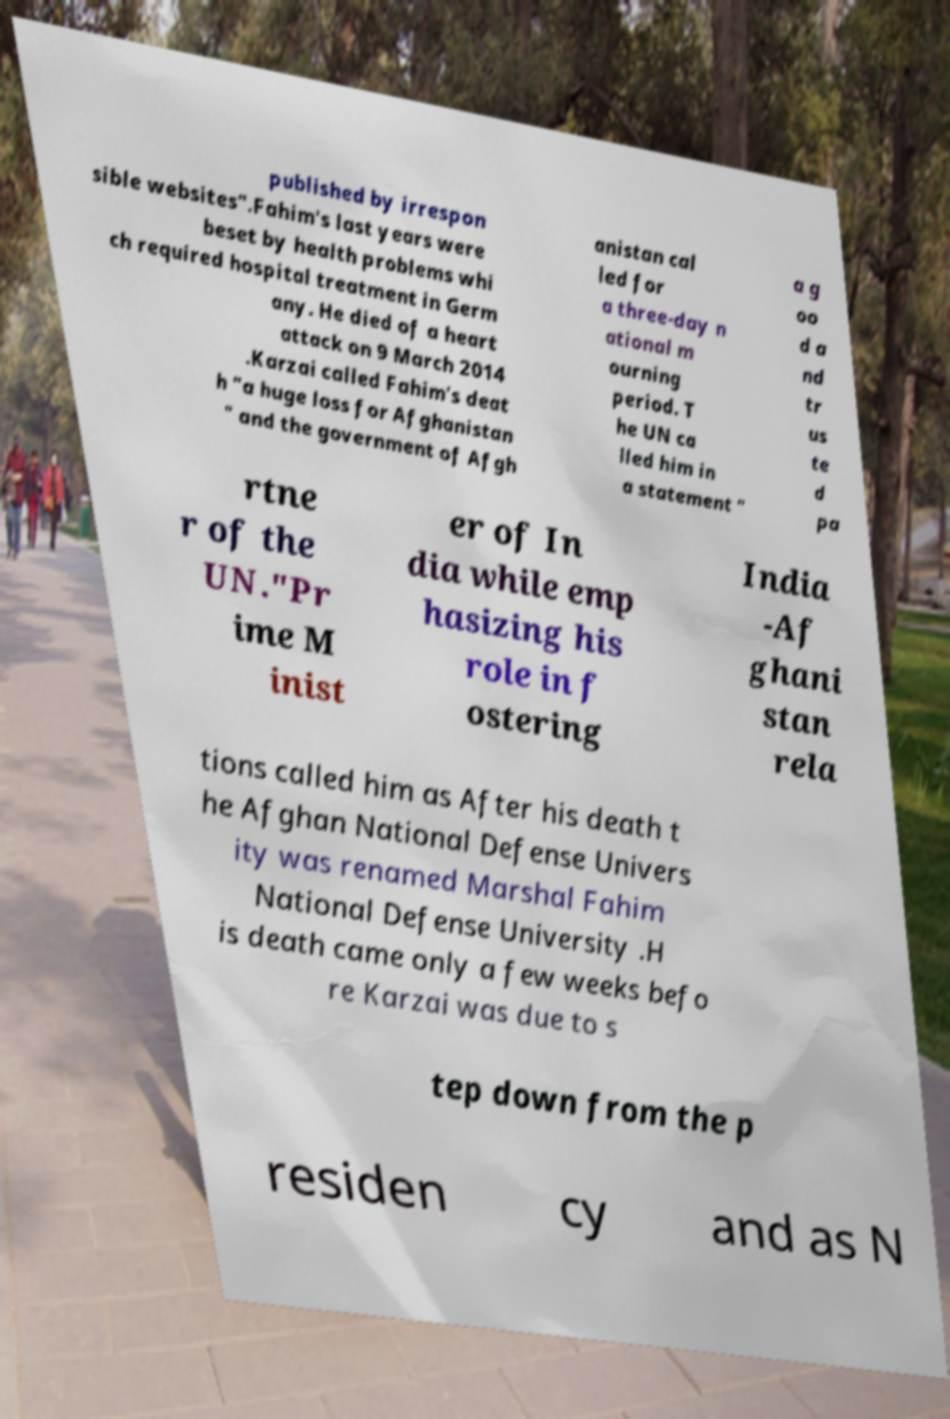Please read and relay the text visible in this image. What does it say? published by irrespon sible websites".Fahim's last years were beset by health problems whi ch required hospital treatment in Germ any. He died of a heart attack on 9 March 2014 .Karzai called Fahim's deat h "a huge loss for Afghanistan " and the government of Afgh anistan cal led for a three-day n ational m ourning period. T he UN ca lled him in a statement " a g oo d a nd tr us te d pa rtne r of the UN."Pr ime M inist er of In dia while emp hasizing his role in f ostering India -Af ghani stan rela tions called him as After his death t he Afghan National Defense Univers ity was renamed Marshal Fahim National Defense University .H is death came only a few weeks befo re Karzai was due to s tep down from the p residen cy and as N 